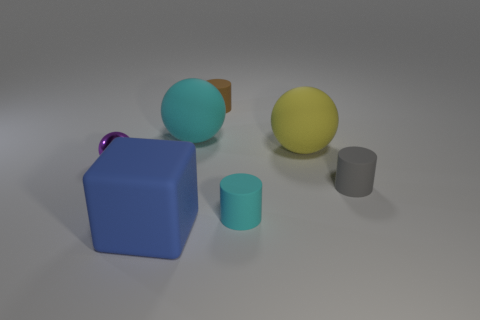How many other objects are there of the same size as the matte cube?
Make the answer very short. 2. There is a tiny cylinder to the right of the big yellow object that is behind the gray object; are there any rubber things in front of it?
Keep it short and to the point. Yes. Does the sphere that is to the left of the large blue rubber block have the same material as the large blue object?
Your answer should be very brief. No. There is another shiny object that is the same shape as the yellow object; what color is it?
Ensure brevity in your answer.  Purple. Is there anything else that is the same shape as the blue thing?
Your answer should be very brief. No. Are there an equal number of tiny purple shiny things that are on the right side of the big blue object and tiny cyan rubber cubes?
Provide a succinct answer. Yes. There is a brown thing; are there any objects on the right side of it?
Make the answer very short. Yes. What size is the rubber ball in front of the cyan thing that is left of the small cylinder behind the shiny ball?
Offer a very short reply. Large. Do the small matte object in front of the gray object and the tiny thing to the right of the small cyan cylinder have the same shape?
Your response must be concise. Yes. What size is the cyan object that is the same shape as the big yellow object?
Make the answer very short. Large. 